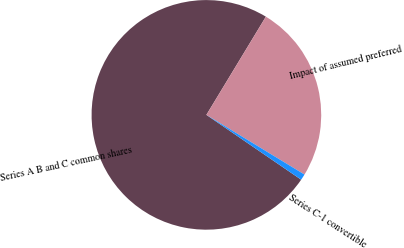<chart> <loc_0><loc_0><loc_500><loc_500><pie_chart><fcel>Series A B and C common shares<fcel>Impact of assumed preferred<fcel>Series C-1 convertible<nl><fcel>74.12%<fcel>25.03%<fcel>0.85%<nl></chart> 